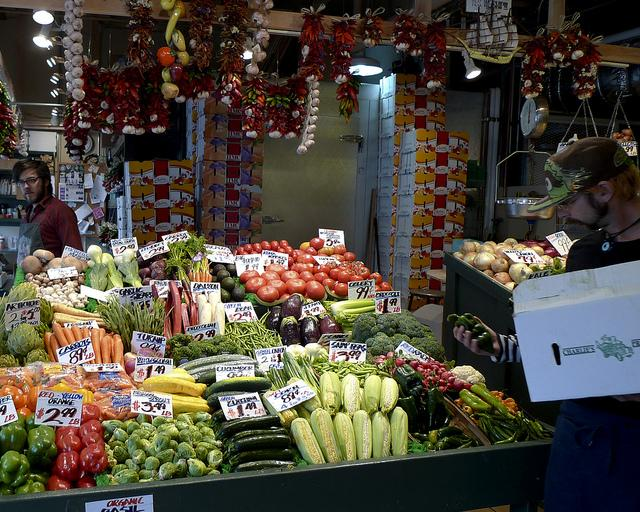Which vegetable is likely the most expensive item by piece or pound? Please explain your reasoning. artichoke. The most expensive item is artichokes. 